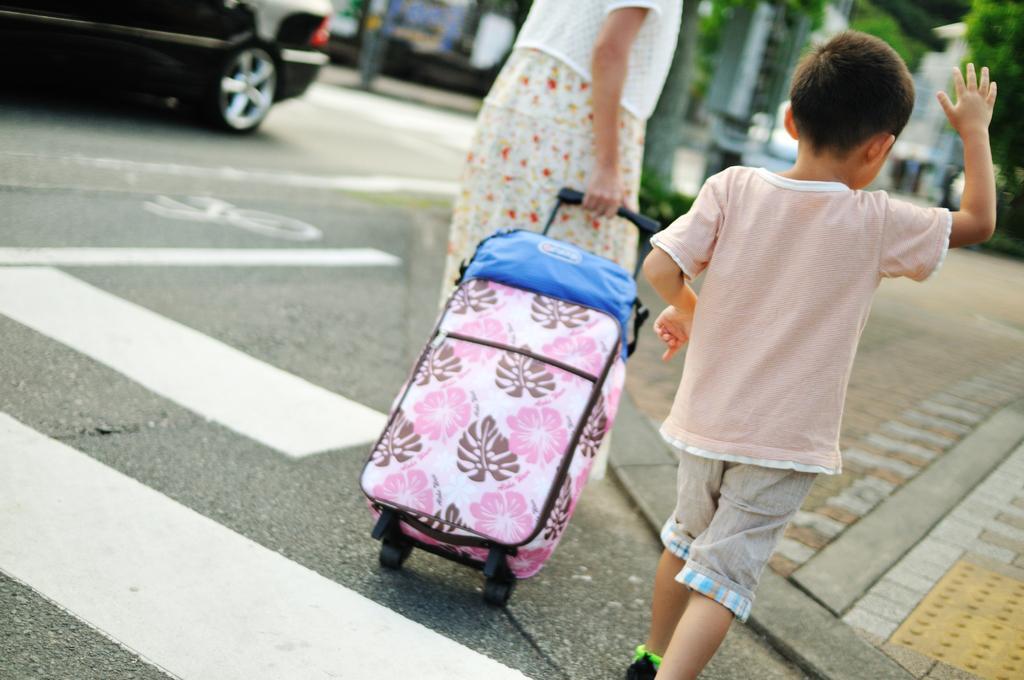In one or two sentences, can you explain what this image depicts? there is a outside of the street there are two people walking on street the right side the boy walking on the street and the other side the woman is walking on the street and she is holding the bag and the left side the car is parking the many trees and poles are present on the road. 